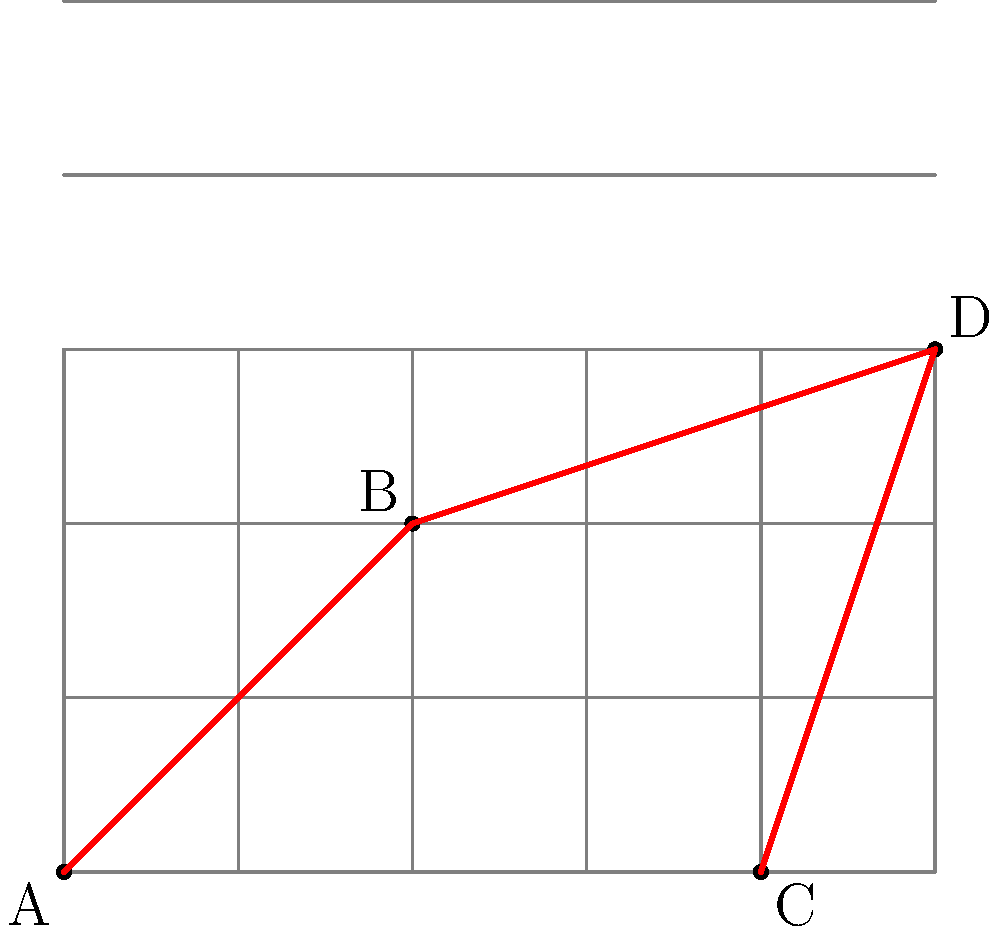In a network routing optimization problem, four nodes (A, B, C, and D) are placed on a grid as shown. Each unit on the grid represents 1 km. What is the total length of the shortest path that connects all four nodes, assuming the path can only follow the grid lines? To find the shortest path that connects all four nodes while following the grid lines, we need to use the concept of Manhattan distance and consider all possible routes. Let's approach this step-by-step:

1) First, we need to identify the coordinates of each node:
   A: (0,0), B: (2,2), C: (4,0), D: (5,3)

2) We need to connect all nodes, but the order matters. We'll consider the most promising routes:

3) Route 1: A -> B -> D -> C
   - A to B: |2-0| + |2-0| = 4 km
   - B to D: |5-2| + |3-2| = 4 km
   - D to C: |4-5| + |0-3| = 4 km
   Total: 4 + 4 + 4 = 12 km

4) Route 2: A -> C -> D -> B
   - A to C: |4-0| + |0-0| = 4 km
   - C to D: |5-4| + |3-0| = 4 km
   - D to B: |2-5| + |2-3| = 4 km
   Total: 4 + 4 + 4 = 12 km

5) Other routes will be longer because they involve backtracking.

6) Both Route 1 and Route 2 give the same minimal distance of 12 km.

Therefore, the shortest path that connects all four nodes has a total length of 12 km.
Answer: 12 km 